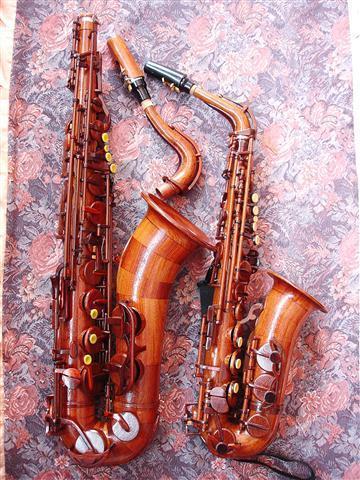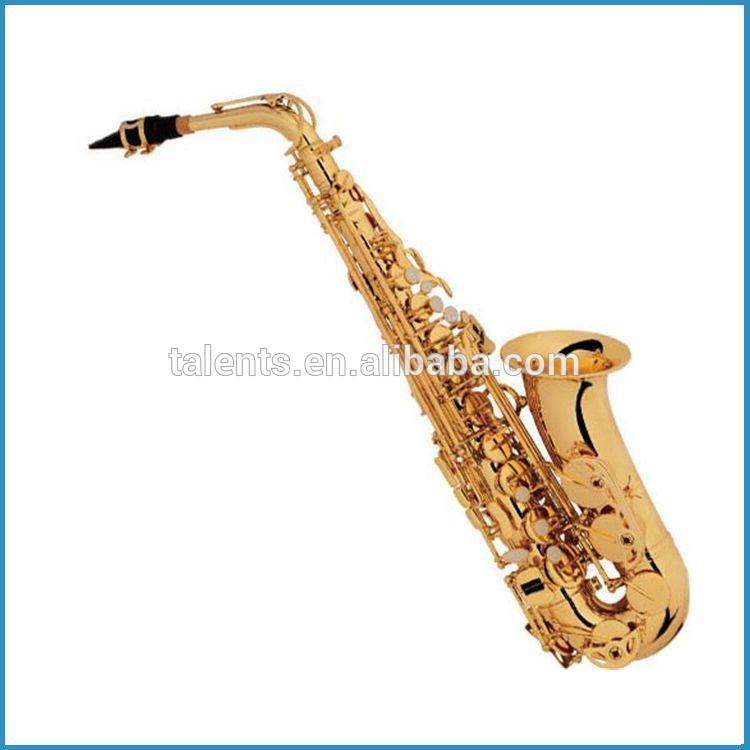The first image is the image on the left, the second image is the image on the right. Considering the images on both sides, is "There are at least three saxophones." valid? Answer yes or no. Yes. The first image is the image on the left, the second image is the image on the right. Assess this claim about the two images: "An image shows at least two wooden instruments displayed side-by-side.". Correct or not? Answer yes or no. Yes. 